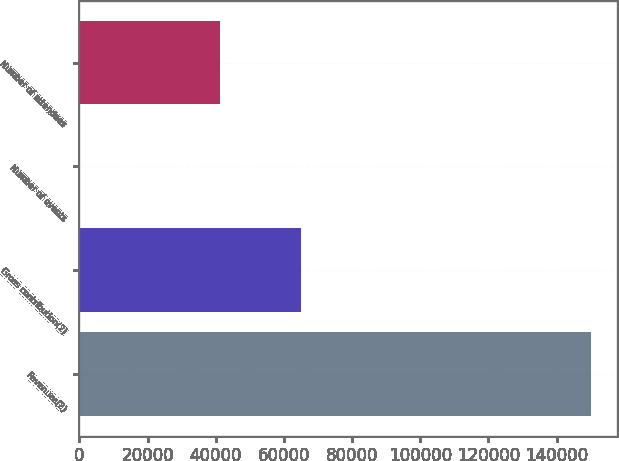<chart> <loc_0><loc_0><loc_500><loc_500><bar_chart><fcel>Revenues(2)<fcel>Gross contribution(2)<fcel>Number of events<fcel>Number of attendees<nl><fcel>150080<fcel>64954<fcel>70<fcel>41352<nl></chart> 